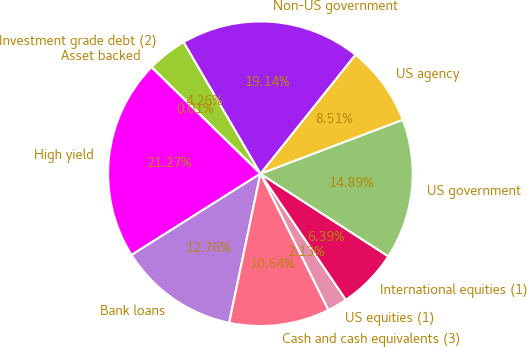Convert chart. <chart><loc_0><loc_0><loc_500><loc_500><pie_chart><fcel>US equities (1)<fcel>International equities (1)<fcel>US government<fcel>US agency<fcel>Non-US government<fcel>Investment grade debt (2)<fcel>Asset backed<fcel>High yield<fcel>Bank loans<fcel>Cash and cash equivalents (3)<nl><fcel>2.13%<fcel>6.39%<fcel>14.89%<fcel>8.51%<fcel>19.14%<fcel>4.26%<fcel>0.01%<fcel>21.27%<fcel>12.76%<fcel>10.64%<nl></chart> 